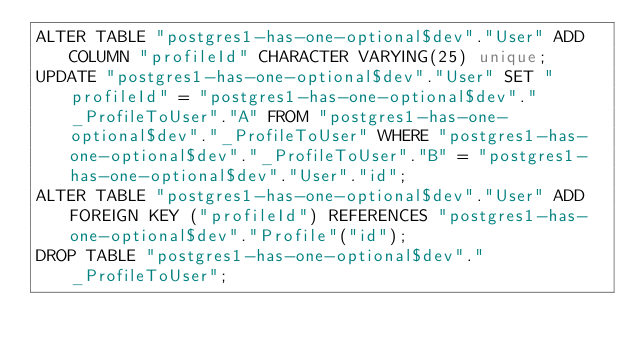Convert code to text. <code><loc_0><loc_0><loc_500><loc_500><_SQL_>ALTER TABLE "postgres1-has-one-optional$dev"."User" ADD COLUMN "profileId" CHARACTER VARYING(25) unique;
UPDATE "postgres1-has-one-optional$dev"."User" SET "profileId" = "postgres1-has-one-optional$dev"."_ProfileToUser"."A" FROM "postgres1-has-one-optional$dev"."_ProfileToUser" WHERE "postgres1-has-one-optional$dev"."_ProfileToUser"."B" = "postgres1-has-one-optional$dev"."User"."id";
ALTER TABLE "postgres1-has-one-optional$dev"."User" ADD FOREIGN KEY ("profileId") REFERENCES "postgres1-has-one-optional$dev"."Profile"("id");
DROP TABLE "postgres1-has-one-optional$dev"."_ProfileToUser";</code> 